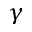Convert formula to latex. <formula><loc_0><loc_0><loc_500><loc_500>\gamma</formula> 